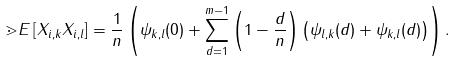Convert formula to latex. <formula><loc_0><loc_0><loc_500><loc_500>\mathbb { m } { E } \left [ X _ { i , k } X _ { i , l } \right ] = \frac { 1 } { n } \left ( \psi _ { k , l } ( 0 ) + \sum _ { d = 1 } ^ { m - 1 } \left ( 1 - \frac { d } { n } \right ) \left ( \psi _ { l , k } ( d ) + \psi _ { k , l } ( d ) \right ) \right ) .</formula> 